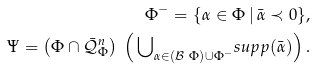Convert formula to latex. <formula><loc_0><loc_0><loc_500><loc_500>\Phi ^ { - } = \{ \alpha \in \Phi \, | \, \bar { \alpha } \prec 0 \} , \\ \Psi = \left ( \Phi \cap \bar { \mathcal { Q } } _ { \Phi } ^ { n } \right ) \ \left ( \, { \bigcup } _ { \alpha \in ( \mathcal { B } \ \Phi ) \cup { \Phi ^ { - } } } s u p p ( \bar { \alpha } ) \right ) .</formula> 